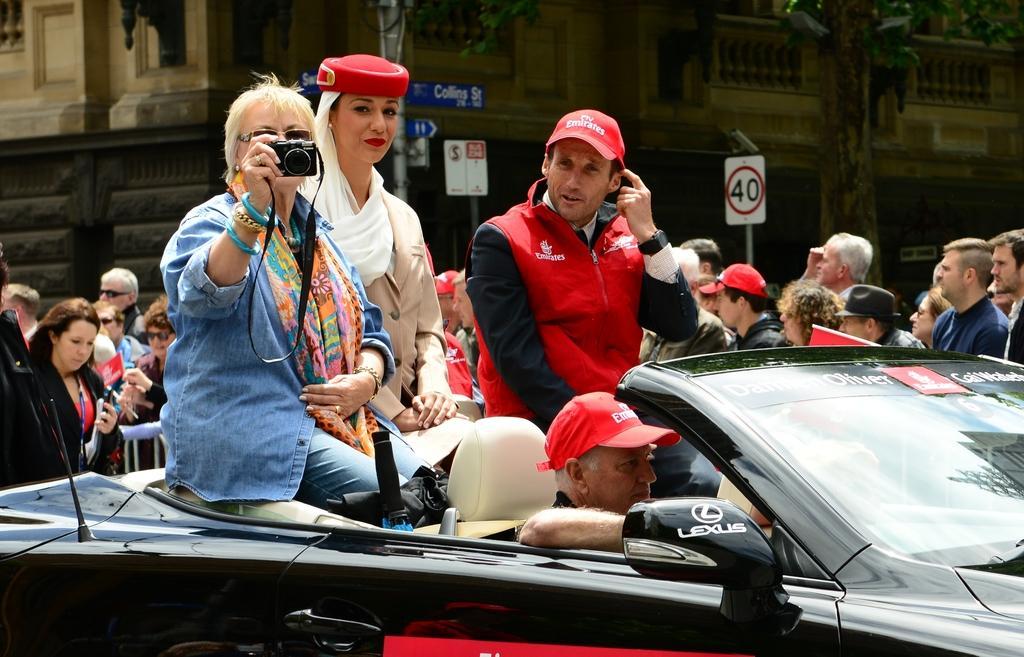Could you give a brief overview of what you see in this image? In this picture there are three people one of them is sitting in the car and taking photographs from the camera and is a person riding the car in the backdrop the crowd standing and there is a building on the left and there are precaution boards 